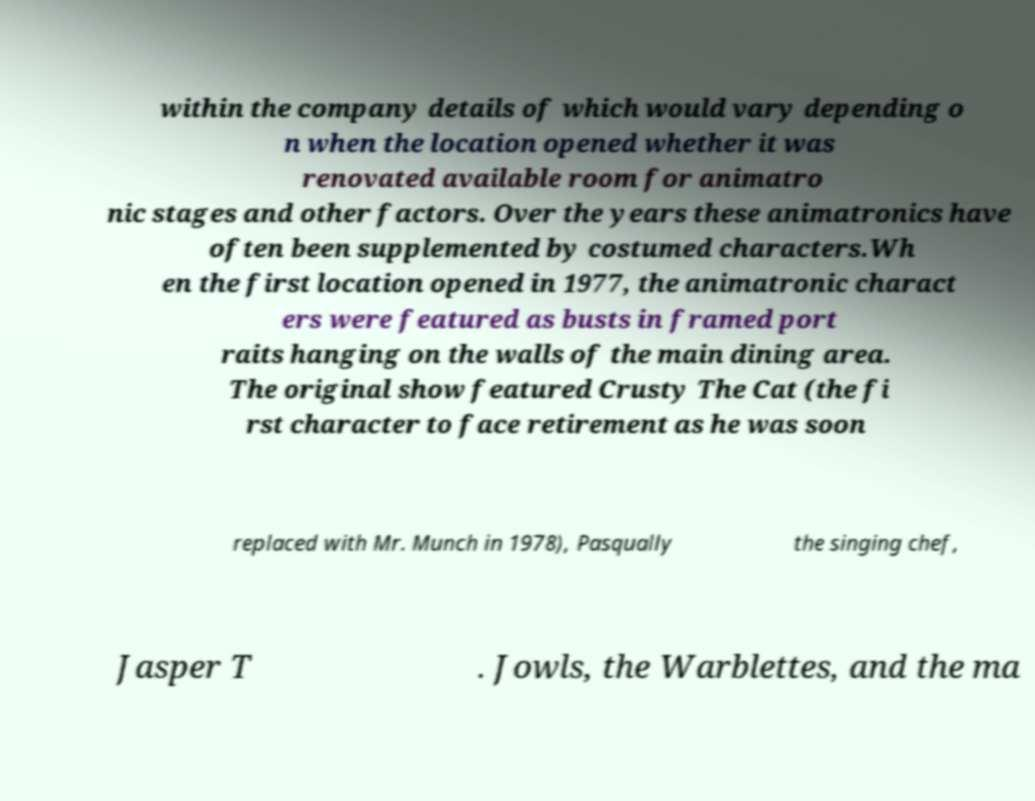There's text embedded in this image that I need extracted. Can you transcribe it verbatim? within the company details of which would vary depending o n when the location opened whether it was renovated available room for animatro nic stages and other factors. Over the years these animatronics have often been supplemented by costumed characters.Wh en the first location opened in 1977, the animatronic charact ers were featured as busts in framed port raits hanging on the walls of the main dining area. The original show featured Crusty The Cat (the fi rst character to face retirement as he was soon replaced with Mr. Munch in 1978), Pasqually the singing chef, Jasper T . Jowls, the Warblettes, and the ma 